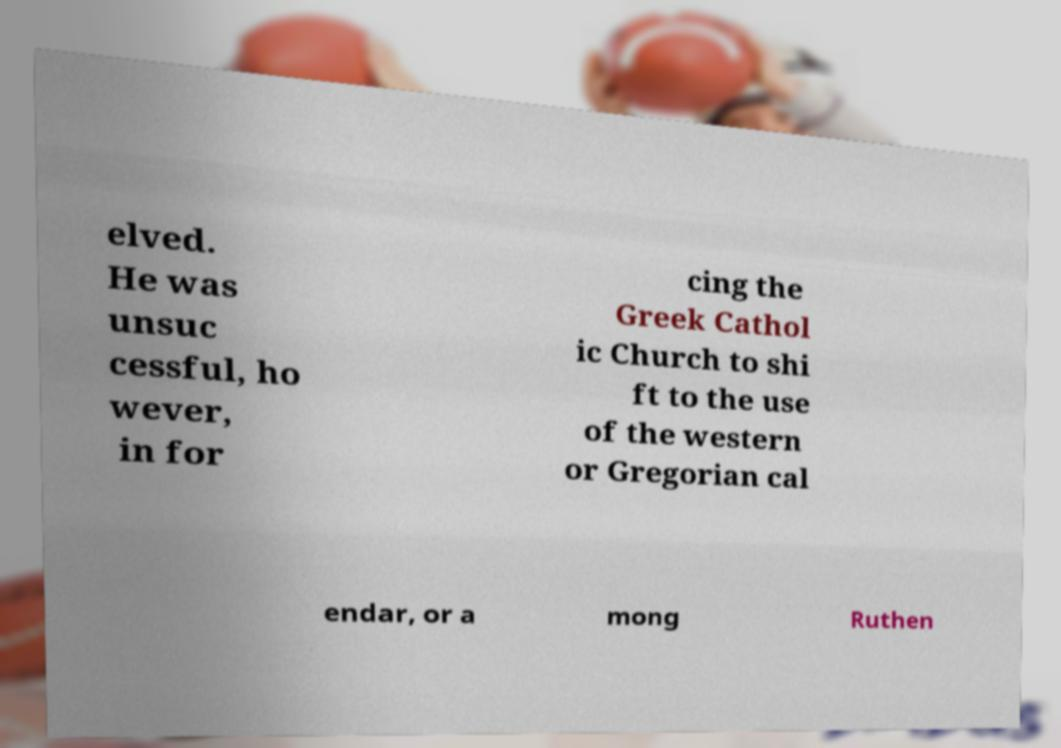I need the written content from this picture converted into text. Can you do that? elved. He was unsuc cessful, ho wever, in for cing the Greek Cathol ic Church to shi ft to the use of the western or Gregorian cal endar, or a mong Ruthen 